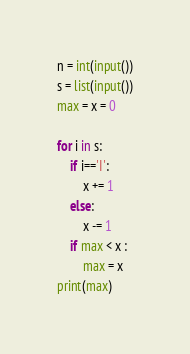Convert code to text. <code><loc_0><loc_0><loc_500><loc_500><_Python_>n = int(input())
s = list(input())
max = x = 0

for i in s:
    if i=='I':
        x += 1
    else:
        x -= 1
    if max < x :
        max = x
print(max)</code> 